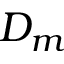Convert formula to latex. <formula><loc_0><loc_0><loc_500><loc_500>D _ { m }</formula> 